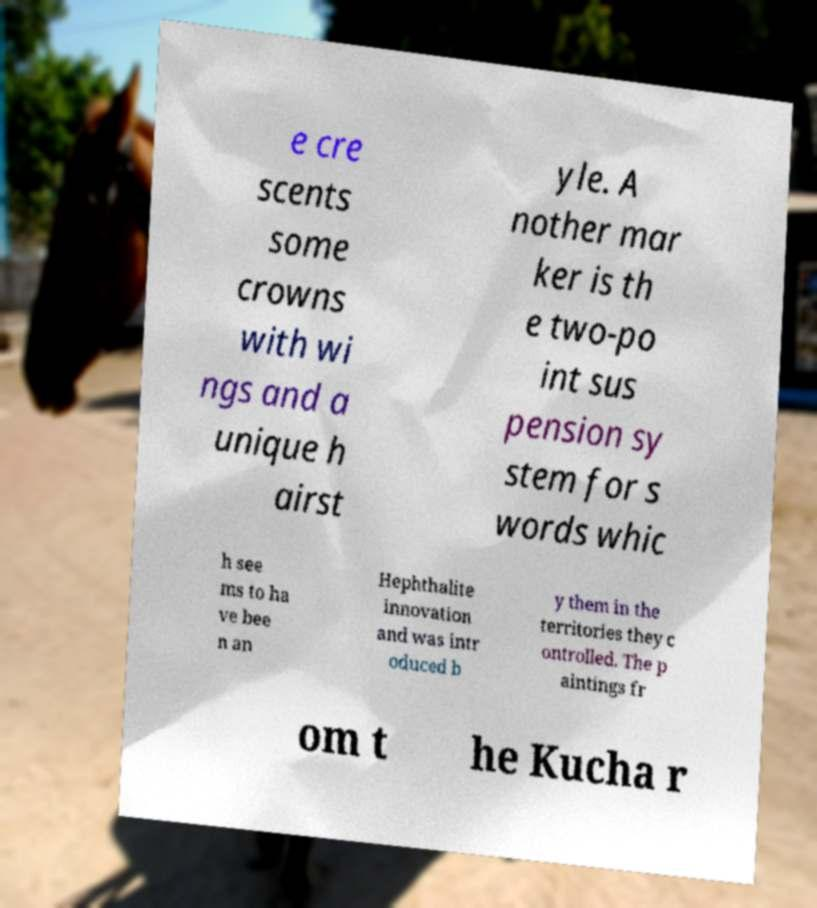I need the written content from this picture converted into text. Can you do that? e cre scents some crowns with wi ngs and a unique h airst yle. A nother mar ker is th e two-po int sus pension sy stem for s words whic h see ms to ha ve bee n an Hephthalite innovation and was intr oduced b y them in the territories they c ontrolled. The p aintings fr om t he Kucha r 